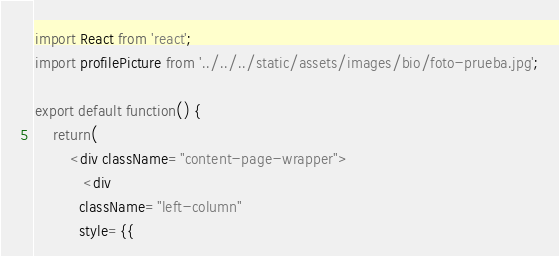<code> <loc_0><loc_0><loc_500><loc_500><_JavaScript_>import React from 'react';
import profilePicture from '../../../static/assets/images/bio/foto-prueba.jpg';

export default function() {
    return(
        <div className="content-page-wrapper">
           <div
          className="left-column"
          style={{</code> 